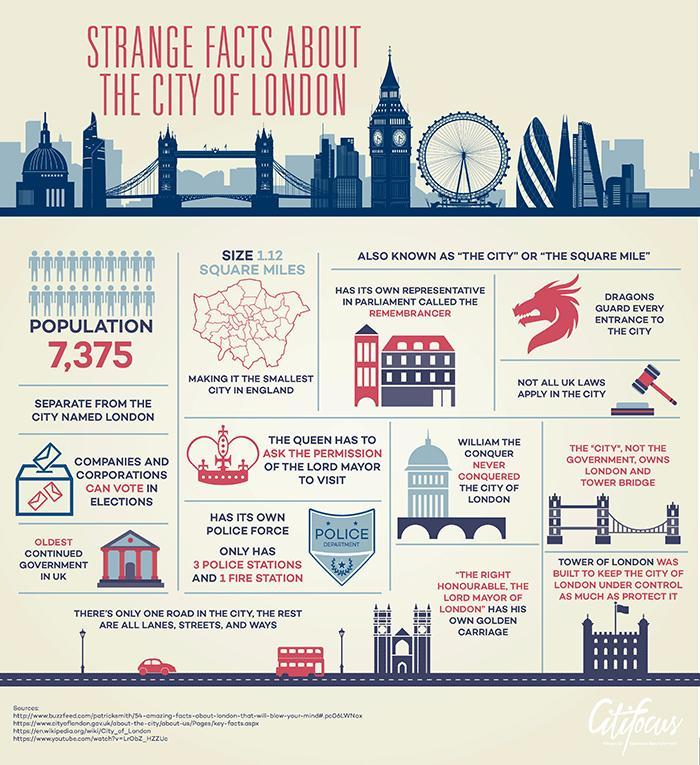What special vehicle does the Lord Mayor of London have?
Answer the question with a short phrase. golden carriage Who owns London and Tower Bridge? The City Which city is also known as 'The City' or 'The Square Mile'? The City of London Which city has a population of 7,375? The City of London What is the city's parliament representative called? remembrancer What legendary creature guards each of the city entrances? Dragons What is the area of the City of London? 1.12 square miles What was built to protect and control the City of London? Tower of London Which is the smallest city in England? The City of London Who requires the Lord Mayor of London's permission to visit the city? The Queen 